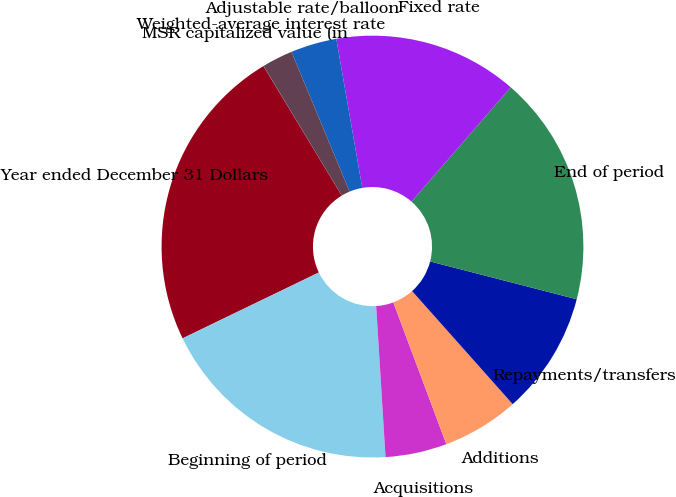Convert chart. <chart><loc_0><loc_0><loc_500><loc_500><pie_chart><fcel>Year ended December 31 Dollars<fcel>Beginning of period<fcel>Acquisitions<fcel>Additions<fcel>Repayments/transfers<fcel>End of period<fcel>Fixed rate<fcel>Adjustable rate/balloon<fcel>Weighted-average interest rate<fcel>MSR capitalized value (in<nl><fcel>23.52%<fcel>18.82%<fcel>4.71%<fcel>5.88%<fcel>9.41%<fcel>17.64%<fcel>14.12%<fcel>3.53%<fcel>2.36%<fcel>0.01%<nl></chart> 